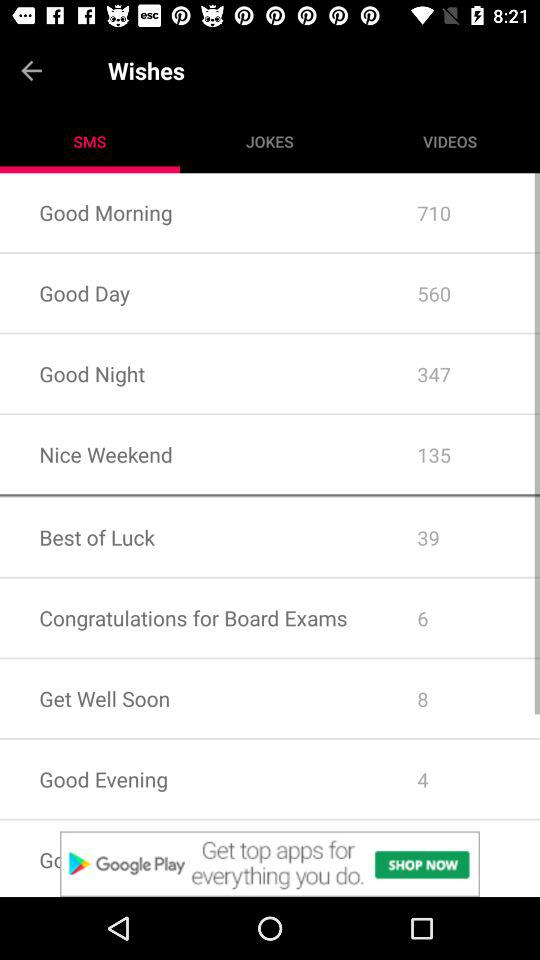How many messages of "Good Day" are there? There are 560 messages of "Good Day". 